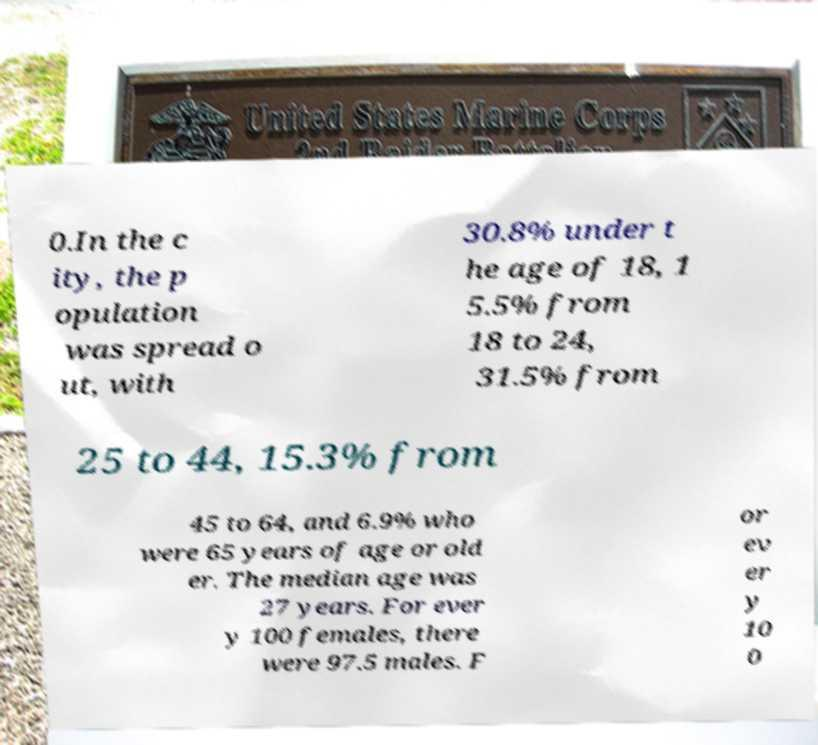Can you read and provide the text displayed in the image?This photo seems to have some interesting text. Can you extract and type it out for me? 0.In the c ity, the p opulation was spread o ut, with 30.8% under t he age of 18, 1 5.5% from 18 to 24, 31.5% from 25 to 44, 15.3% from 45 to 64, and 6.9% who were 65 years of age or old er. The median age was 27 years. For ever y 100 females, there were 97.5 males. F or ev er y 10 0 